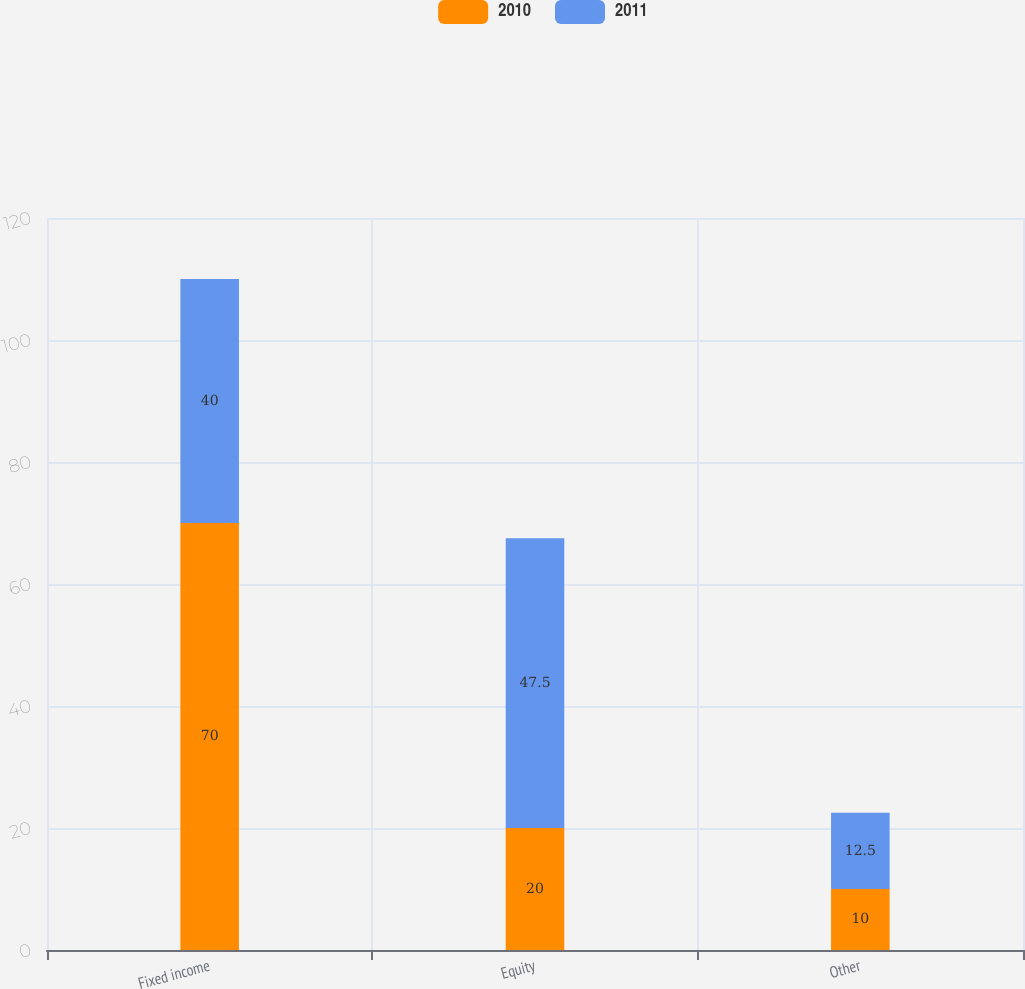Convert chart. <chart><loc_0><loc_0><loc_500><loc_500><stacked_bar_chart><ecel><fcel>Fixed income<fcel>Equity<fcel>Other<nl><fcel>2010<fcel>70<fcel>20<fcel>10<nl><fcel>2011<fcel>40<fcel>47.5<fcel>12.5<nl></chart> 